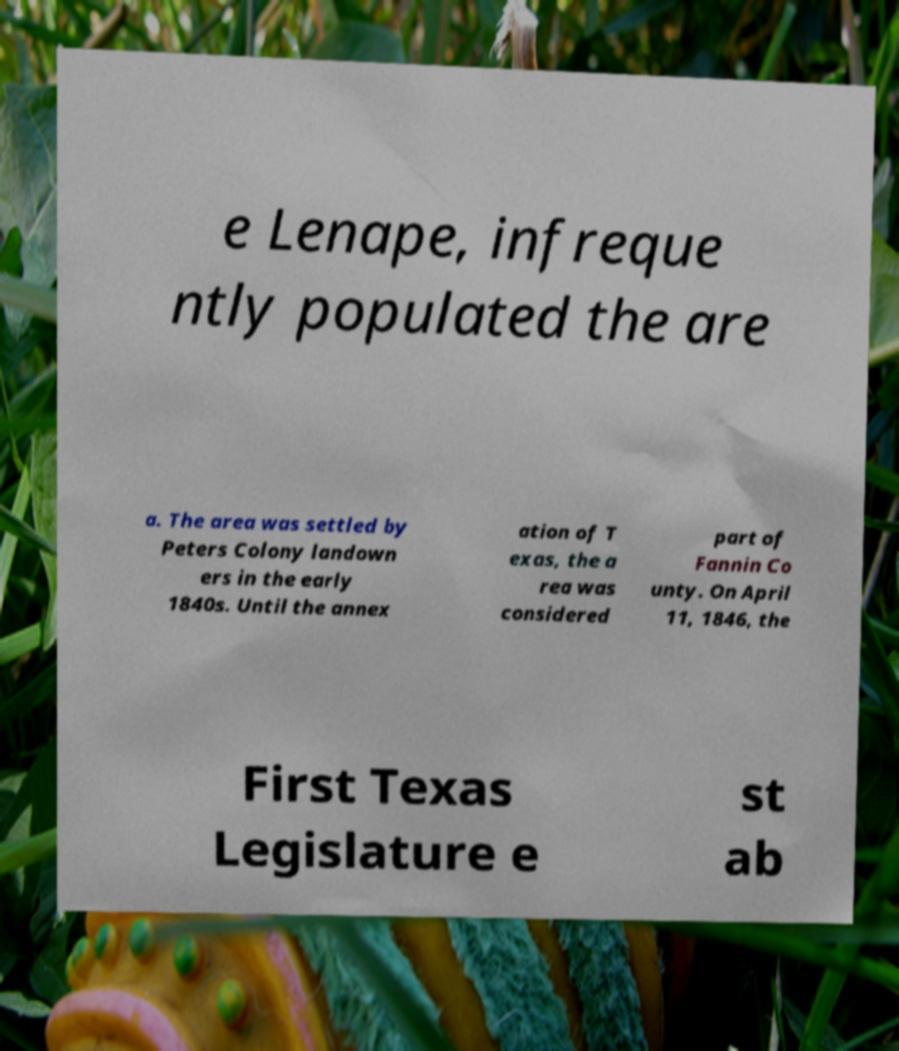Please identify and transcribe the text found in this image. e Lenape, infreque ntly populated the are a. The area was settled by Peters Colony landown ers in the early 1840s. Until the annex ation of T exas, the a rea was considered part of Fannin Co unty. On April 11, 1846, the First Texas Legislature e st ab 